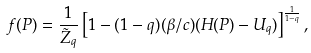Convert formula to latex. <formula><loc_0><loc_0><loc_500><loc_500>f ( { P } ) = \frac { 1 } { \tilde { Z } _ { q } } \left [ 1 - ( 1 - q ) ( \beta / c ) ( H ( { P } ) - U _ { q } ) \right ] ^ { \frac { 1 } { 1 - q } } ,</formula> 